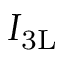<formula> <loc_0><loc_0><loc_500><loc_500>\, I _ { 3 L }</formula> 